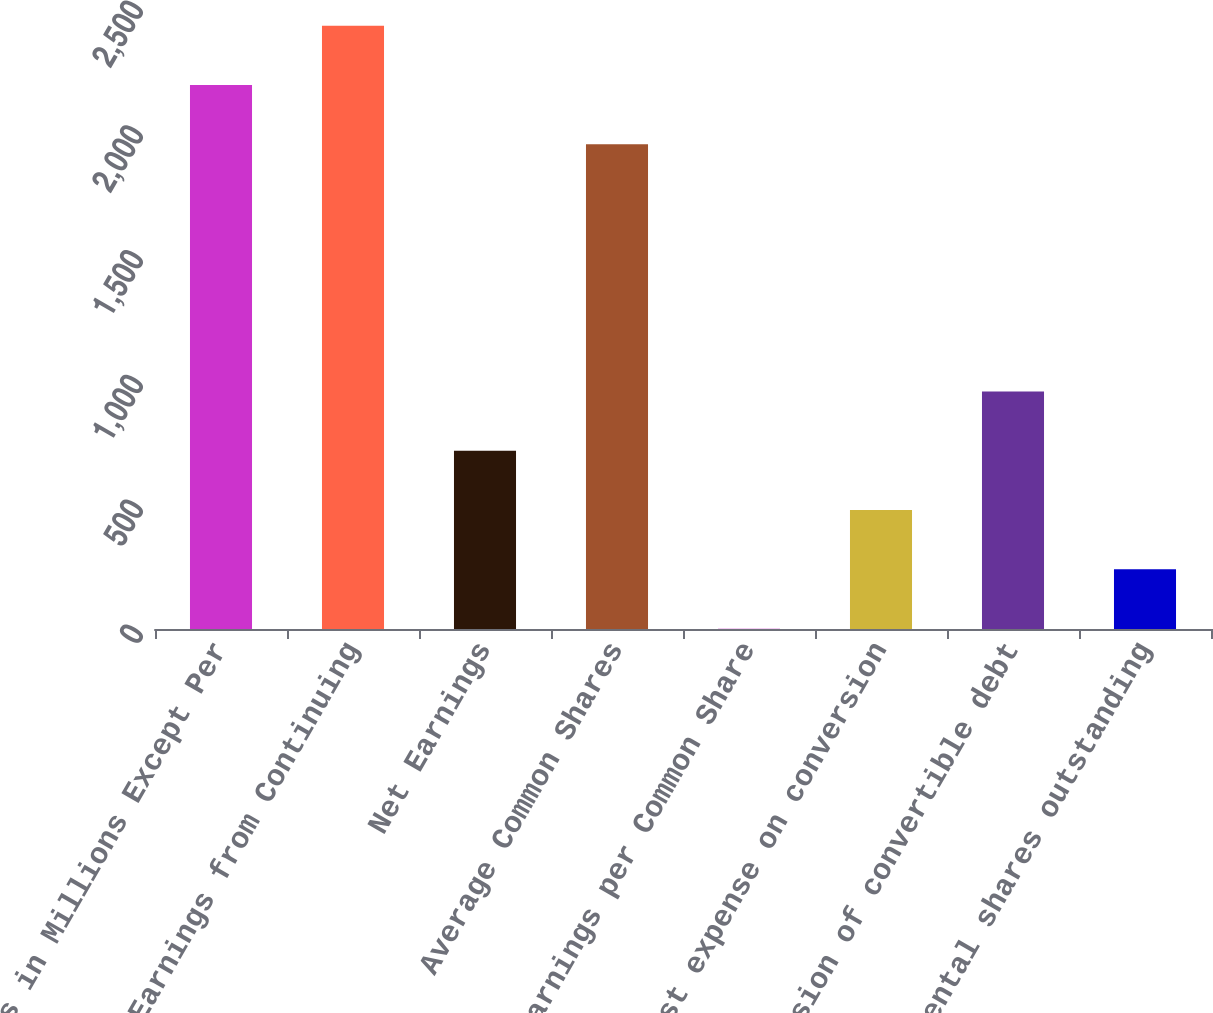Convert chart. <chart><loc_0><loc_0><loc_500><loc_500><bar_chart><fcel>Amounts in Millions Except Per<fcel>Earnings from Continuing<fcel>Net Earnings<fcel>Average Common Shares<fcel>Net Earnings per Common Share<fcel>Interest expense on conversion<fcel>Conversion of convertible debt<fcel>Incremental shares outstanding<nl><fcel>2179.68<fcel>2417.36<fcel>714.27<fcel>1942<fcel>1.23<fcel>476.59<fcel>951.95<fcel>238.91<nl></chart> 